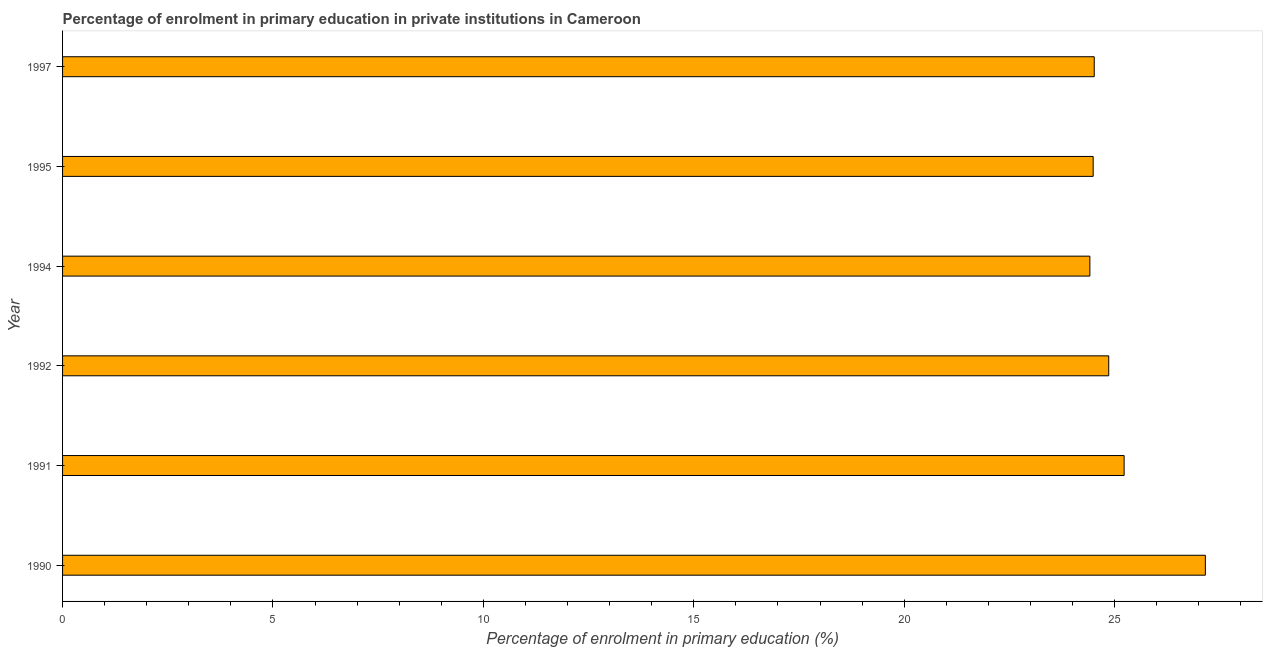Does the graph contain grids?
Keep it short and to the point. No. What is the title of the graph?
Make the answer very short. Percentage of enrolment in primary education in private institutions in Cameroon. What is the label or title of the X-axis?
Offer a very short reply. Percentage of enrolment in primary education (%). What is the enrolment percentage in primary education in 1992?
Ensure brevity in your answer.  24.86. Across all years, what is the maximum enrolment percentage in primary education?
Your response must be concise. 27.16. Across all years, what is the minimum enrolment percentage in primary education?
Your response must be concise. 24.41. In which year was the enrolment percentage in primary education maximum?
Make the answer very short. 1990. In which year was the enrolment percentage in primary education minimum?
Offer a very short reply. 1994. What is the sum of the enrolment percentage in primary education?
Give a very brief answer. 150.66. What is the difference between the enrolment percentage in primary education in 1994 and 1995?
Offer a terse response. -0.08. What is the average enrolment percentage in primary education per year?
Provide a succinct answer. 25.11. What is the median enrolment percentage in primary education?
Give a very brief answer. 24.69. What is the ratio of the enrolment percentage in primary education in 1992 to that in 1994?
Your answer should be very brief. 1.02. Is the enrolment percentage in primary education in 1991 less than that in 1994?
Give a very brief answer. No. Is the difference between the enrolment percentage in primary education in 1990 and 1992 greater than the difference between any two years?
Your response must be concise. No. What is the difference between the highest and the second highest enrolment percentage in primary education?
Make the answer very short. 1.93. Is the sum of the enrolment percentage in primary education in 1992 and 1997 greater than the maximum enrolment percentage in primary education across all years?
Provide a short and direct response. Yes. What is the difference between the highest and the lowest enrolment percentage in primary education?
Your answer should be very brief. 2.74. In how many years, is the enrolment percentage in primary education greater than the average enrolment percentage in primary education taken over all years?
Your response must be concise. 2. What is the Percentage of enrolment in primary education (%) in 1990?
Give a very brief answer. 27.16. What is the Percentage of enrolment in primary education (%) of 1991?
Offer a terse response. 25.23. What is the Percentage of enrolment in primary education (%) of 1992?
Ensure brevity in your answer.  24.86. What is the Percentage of enrolment in primary education (%) in 1994?
Your answer should be compact. 24.41. What is the Percentage of enrolment in primary education (%) in 1995?
Give a very brief answer. 24.49. What is the Percentage of enrolment in primary education (%) of 1997?
Your answer should be compact. 24.52. What is the difference between the Percentage of enrolment in primary education (%) in 1990 and 1991?
Your answer should be very brief. 1.93. What is the difference between the Percentage of enrolment in primary education (%) in 1990 and 1992?
Your response must be concise. 2.3. What is the difference between the Percentage of enrolment in primary education (%) in 1990 and 1994?
Give a very brief answer. 2.74. What is the difference between the Percentage of enrolment in primary education (%) in 1990 and 1995?
Your answer should be compact. 2.67. What is the difference between the Percentage of enrolment in primary education (%) in 1990 and 1997?
Your answer should be very brief. 2.64. What is the difference between the Percentage of enrolment in primary education (%) in 1991 and 1992?
Provide a succinct answer. 0.37. What is the difference between the Percentage of enrolment in primary education (%) in 1991 and 1994?
Your answer should be very brief. 0.81. What is the difference between the Percentage of enrolment in primary education (%) in 1991 and 1995?
Offer a terse response. 0.74. What is the difference between the Percentage of enrolment in primary education (%) in 1991 and 1997?
Provide a short and direct response. 0.71. What is the difference between the Percentage of enrolment in primary education (%) in 1992 and 1994?
Give a very brief answer. 0.45. What is the difference between the Percentage of enrolment in primary education (%) in 1992 and 1995?
Keep it short and to the point. 0.37. What is the difference between the Percentage of enrolment in primary education (%) in 1992 and 1997?
Offer a very short reply. 0.34. What is the difference between the Percentage of enrolment in primary education (%) in 1994 and 1995?
Your answer should be compact. -0.08. What is the difference between the Percentage of enrolment in primary education (%) in 1994 and 1997?
Provide a short and direct response. -0.1. What is the difference between the Percentage of enrolment in primary education (%) in 1995 and 1997?
Make the answer very short. -0.03. What is the ratio of the Percentage of enrolment in primary education (%) in 1990 to that in 1991?
Give a very brief answer. 1.08. What is the ratio of the Percentage of enrolment in primary education (%) in 1990 to that in 1992?
Make the answer very short. 1.09. What is the ratio of the Percentage of enrolment in primary education (%) in 1990 to that in 1994?
Your answer should be compact. 1.11. What is the ratio of the Percentage of enrolment in primary education (%) in 1990 to that in 1995?
Your answer should be compact. 1.11. What is the ratio of the Percentage of enrolment in primary education (%) in 1990 to that in 1997?
Your answer should be compact. 1.11. What is the ratio of the Percentage of enrolment in primary education (%) in 1991 to that in 1994?
Give a very brief answer. 1.03. What is the ratio of the Percentage of enrolment in primary education (%) in 1991 to that in 1997?
Make the answer very short. 1.03. What is the ratio of the Percentage of enrolment in primary education (%) in 1992 to that in 1994?
Offer a terse response. 1.02. What is the ratio of the Percentage of enrolment in primary education (%) in 1992 to that in 1997?
Provide a short and direct response. 1.01. What is the ratio of the Percentage of enrolment in primary education (%) in 1994 to that in 1995?
Ensure brevity in your answer.  1. 